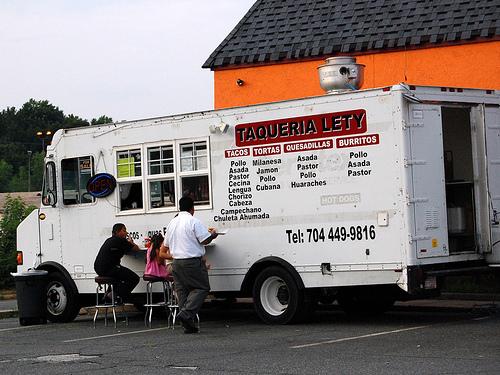What is the color of the truck?
Quick response, please. White. What is the name of the lunch truck?
Write a very short answer. Taqueria lety. How many different types of ice cream is there?
Short answer required. 0. What is the road made of?
Answer briefly. Asphalt. What is being sold from the truck?
Quick response, please. Food. What is served here?
Answer briefly. Mexican food. Can you order breakfast here?
Quick response, please. No. Do they have customers?
Keep it brief. Yes. What does the truck sell?
Short answer required. Food. Does the lunch truck sell chicken quesadillas?
Write a very short answer. Yes. 